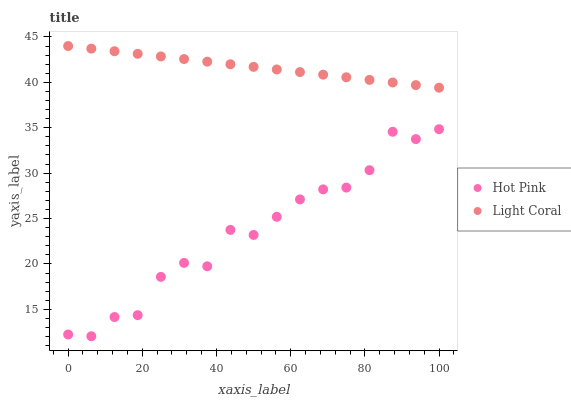Does Hot Pink have the minimum area under the curve?
Answer yes or no. Yes. Does Light Coral have the maximum area under the curve?
Answer yes or no. Yes. Does Hot Pink have the maximum area under the curve?
Answer yes or no. No. Is Light Coral the smoothest?
Answer yes or no. Yes. Is Hot Pink the roughest?
Answer yes or no. Yes. Is Hot Pink the smoothest?
Answer yes or no. No. Does Hot Pink have the lowest value?
Answer yes or no. Yes. Does Light Coral have the highest value?
Answer yes or no. Yes. Does Hot Pink have the highest value?
Answer yes or no. No. Is Hot Pink less than Light Coral?
Answer yes or no. Yes. Is Light Coral greater than Hot Pink?
Answer yes or no. Yes. Does Hot Pink intersect Light Coral?
Answer yes or no. No. 